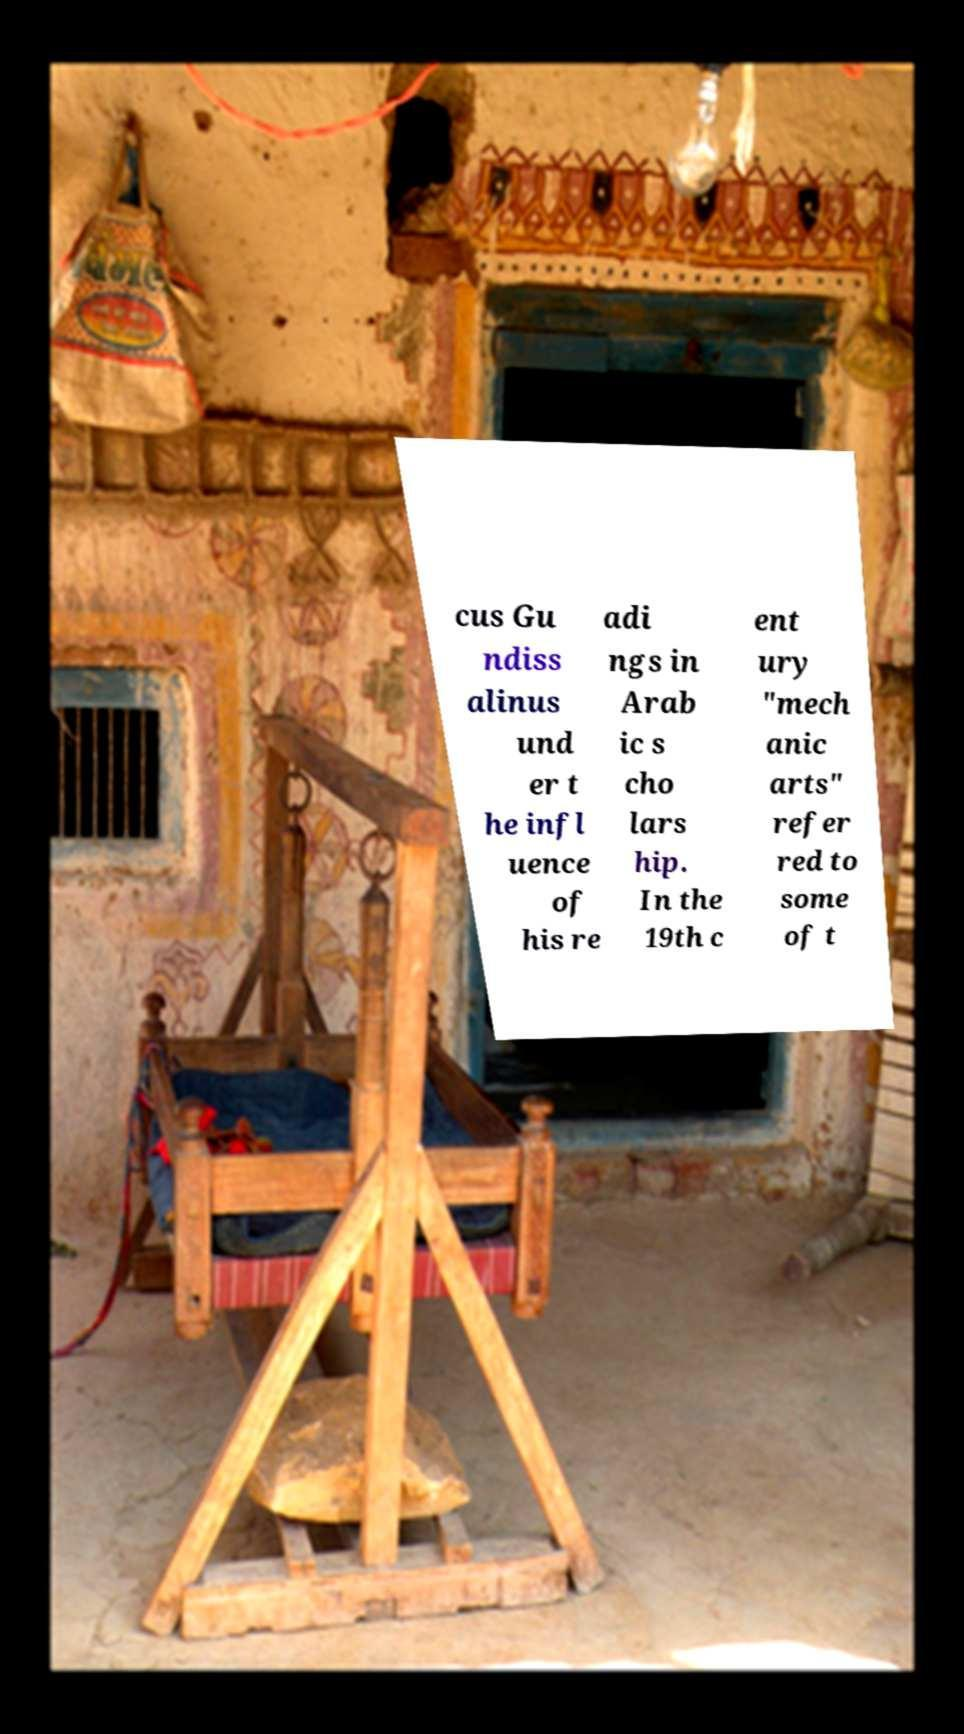There's text embedded in this image that I need extracted. Can you transcribe it verbatim? cus Gu ndiss alinus und er t he infl uence of his re adi ngs in Arab ic s cho lars hip. In the 19th c ent ury "mech anic arts" refer red to some of t 